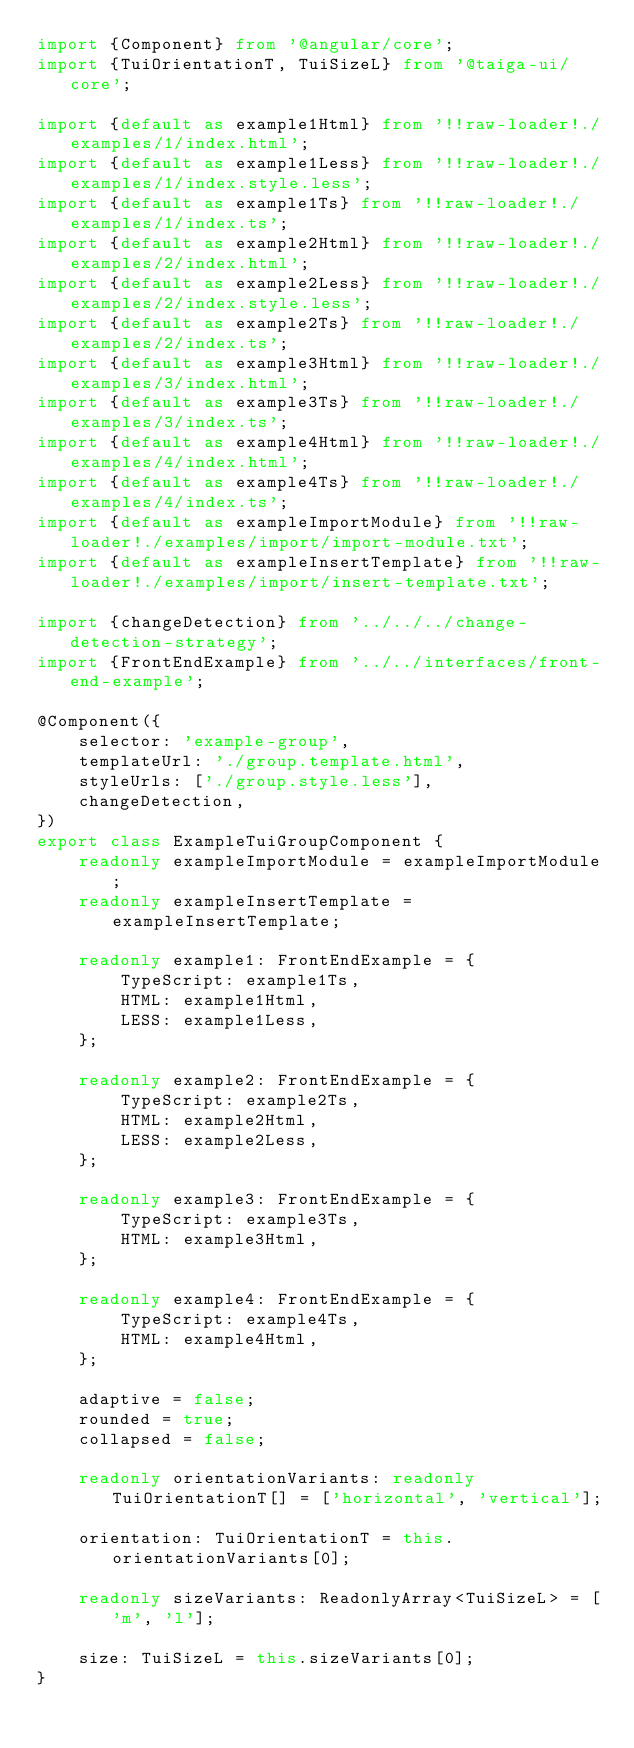Convert code to text. <code><loc_0><loc_0><loc_500><loc_500><_TypeScript_>import {Component} from '@angular/core';
import {TuiOrientationT, TuiSizeL} from '@taiga-ui/core';

import {default as example1Html} from '!!raw-loader!./examples/1/index.html';
import {default as example1Less} from '!!raw-loader!./examples/1/index.style.less';
import {default as example1Ts} from '!!raw-loader!./examples/1/index.ts';
import {default as example2Html} from '!!raw-loader!./examples/2/index.html';
import {default as example2Less} from '!!raw-loader!./examples/2/index.style.less';
import {default as example2Ts} from '!!raw-loader!./examples/2/index.ts';
import {default as example3Html} from '!!raw-loader!./examples/3/index.html';
import {default as example3Ts} from '!!raw-loader!./examples/3/index.ts';
import {default as example4Html} from '!!raw-loader!./examples/4/index.html';
import {default as example4Ts} from '!!raw-loader!./examples/4/index.ts';
import {default as exampleImportModule} from '!!raw-loader!./examples/import/import-module.txt';
import {default as exampleInsertTemplate} from '!!raw-loader!./examples/import/insert-template.txt';

import {changeDetection} from '../../../change-detection-strategy';
import {FrontEndExample} from '../../interfaces/front-end-example';

@Component({
    selector: 'example-group',
    templateUrl: './group.template.html',
    styleUrls: ['./group.style.less'],
    changeDetection,
})
export class ExampleTuiGroupComponent {
    readonly exampleImportModule = exampleImportModule;
    readonly exampleInsertTemplate = exampleInsertTemplate;

    readonly example1: FrontEndExample = {
        TypeScript: example1Ts,
        HTML: example1Html,
        LESS: example1Less,
    };

    readonly example2: FrontEndExample = {
        TypeScript: example2Ts,
        HTML: example2Html,
        LESS: example2Less,
    };

    readonly example3: FrontEndExample = {
        TypeScript: example3Ts,
        HTML: example3Html,
    };

    readonly example4: FrontEndExample = {
        TypeScript: example4Ts,
        HTML: example4Html,
    };

    adaptive = false;
    rounded = true;
    collapsed = false;

    readonly orientationVariants: readonly TuiOrientationT[] = ['horizontal', 'vertical'];

    orientation: TuiOrientationT = this.orientationVariants[0];

    readonly sizeVariants: ReadonlyArray<TuiSizeL> = ['m', 'l'];

    size: TuiSizeL = this.sizeVariants[0];
}
</code> 